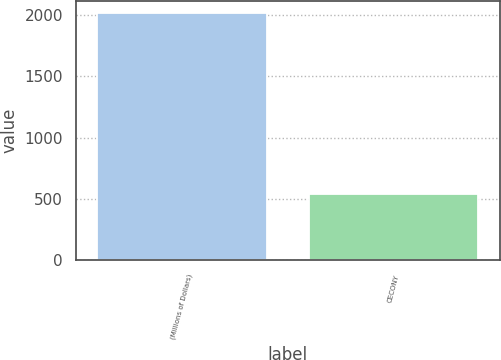<chart> <loc_0><loc_0><loc_500><loc_500><bar_chart><fcel>(Millions of Dollars)<fcel>CECONY<nl><fcel>2014<fcel>541<nl></chart> 